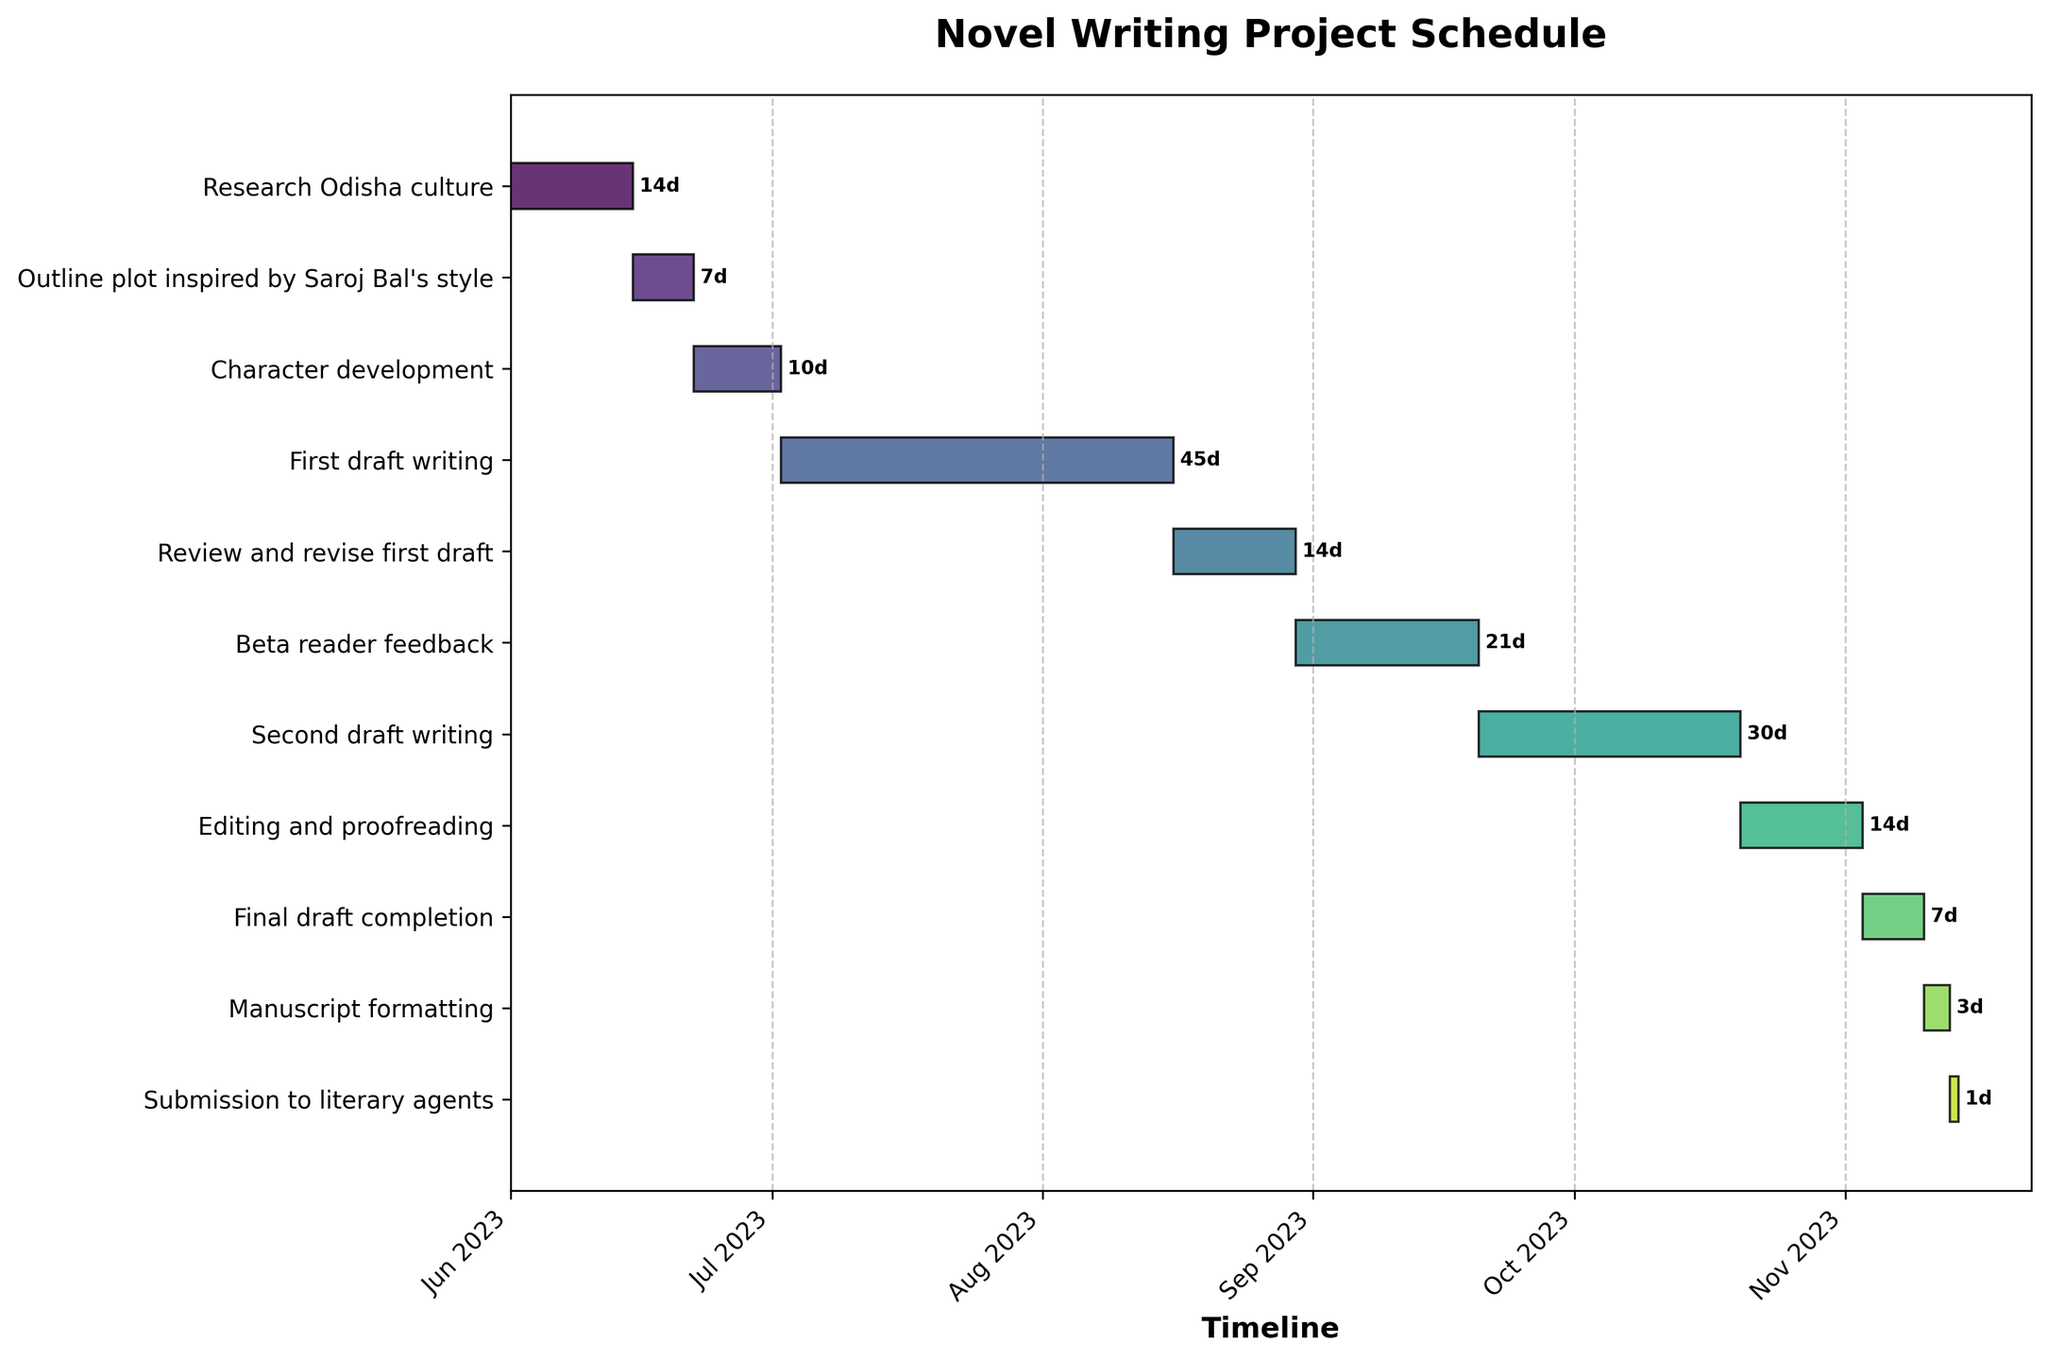What's the total duration of the "First draft writing" phase? The "First draft writing" phase starts on 2023-07-02 and lasts for 45 days, as indicated by the data.
Answer: 45 days What is the title of the Gantt chart? The title of the Gantt chart is displayed at the top of the figure and is "Novel Writing Project Schedule".
Answer: Novel Writing Project Schedule Which phase begins immediately after "Character development"? According to the sequence on the Gantt chart, "First draft writing" starts immediately after "Character development" ends.
Answer: First draft writing How long is the "Beta reader feedback" phase? The "Beta reader feedback" phase lasts for 21 days, as shown on the chart.
Answer: 21 days What is the start date of the "Editing and proofreading" phase? The Gantt chart indicates that the "Editing and proofreading" phase starts on 2023-10-20.
Answer: 2023-10-20 Which phase has the shortest duration? The "Submission to literary agents" phase has the shortest duration of 1 day, as represented in the figure.
Answer: Submission to literary agents How many phases are included in the schedule? There are 11 phases in the project schedule, as counted from the y-axis labels.
Answer: 11 Which phases end in October? According to the chart, the "Second draft writing" and "Editing and proofreading" phases end in October.
Answer: Second draft writing, Editing and proofreading What is the combined duration of "Final draft completion" and "Manuscript formatting"? "Final draft completion" lasts for 7 days and "Manuscript formatting" lasts for 3 days. Adding these together gives 7 + 3 = 10 days.
Answer: 10 days How many days are allocated from the start of "Second draft writing" to the end of "Editing and proofreading"? "Second draft writing" starts on 2023-09-20 and lasts for 30 days (ending on 2023-10-20). "Editing and proofreading" starts on the same day and lasts for an additional 14 days, ending on 2023-11-03. The total span from start to end is 30 + 14 = 44 days.
Answer: 44 days 